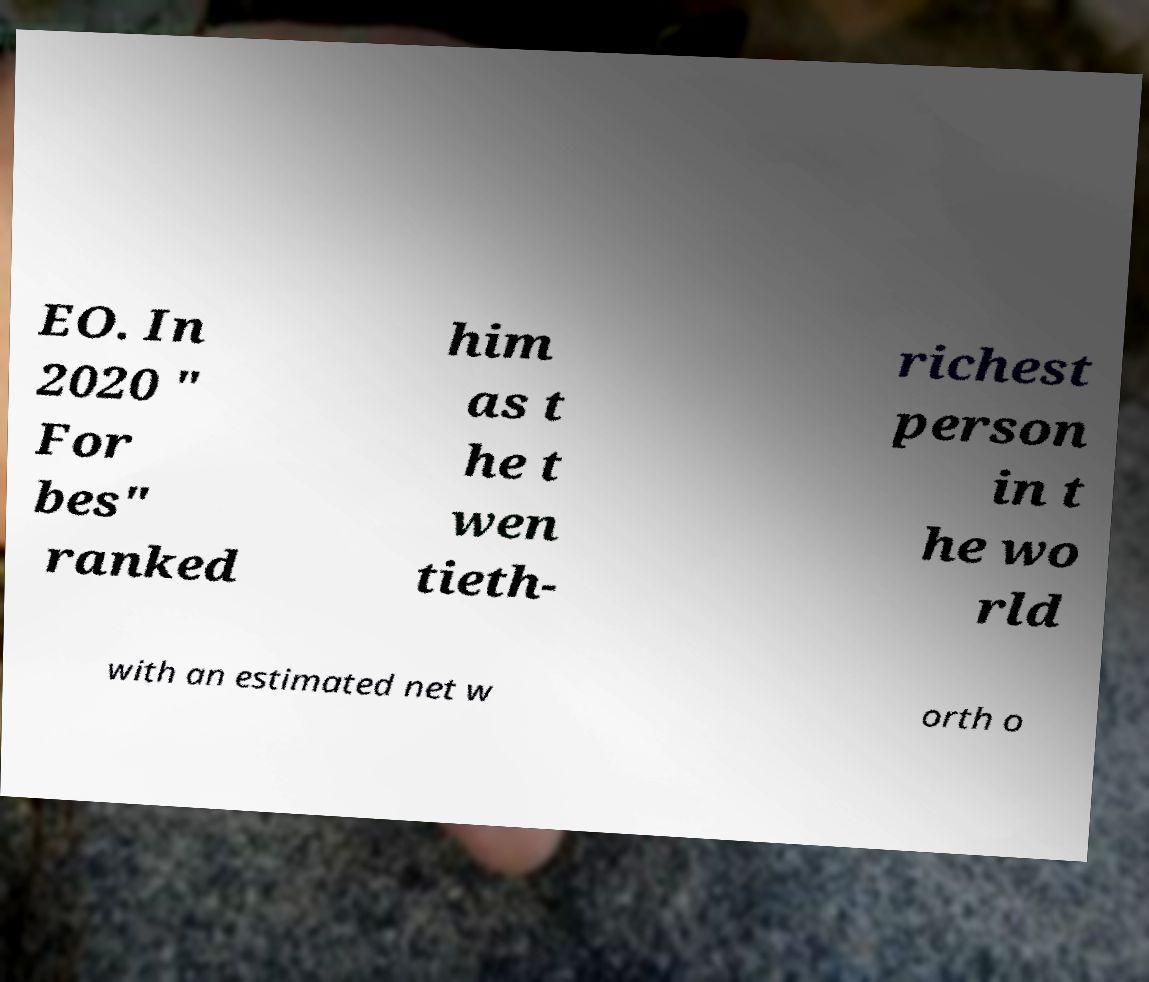Could you extract and type out the text from this image? EO. In 2020 " For bes" ranked him as t he t wen tieth- richest person in t he wo rld with an estimated net w orth o 